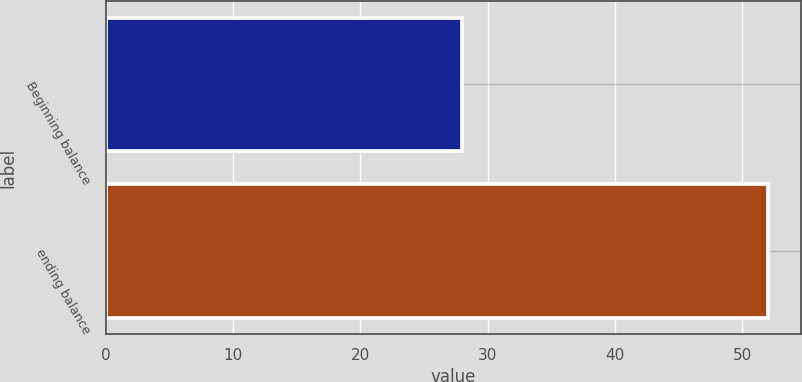<chart> <loc_0><loc_0><loc_500><loc_500><bar_chart><fcel>Beginning balance<fcel>ending balance<nl><fcel>28<fcel>52<nl></chart> 